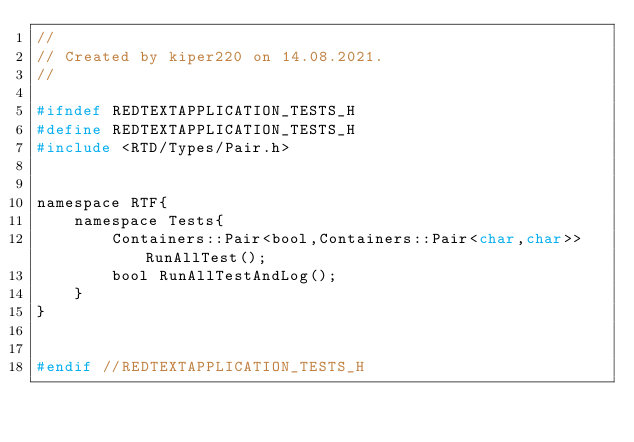Convert code to text. <code><loc_0><loc_0><loc_500><loc_500><_C_>//
// Created by kiper220 on 14.08.2021.
//

#ifndef REDTEXTAPPLICATION_TESTS_H
#define REDTEXTAPPLICATION_TESTS_H
#include <RTD/Types/Pair.h>


namespace RTF{
    namespace Tests{
        Containers::Pair<bool,Containers::Pair<char,char>> RunAllTest();
        bool RunAllTestAndLog();
    }
}


#endif //REDTEXTAPPLICATION_TESTS_H
</code> 